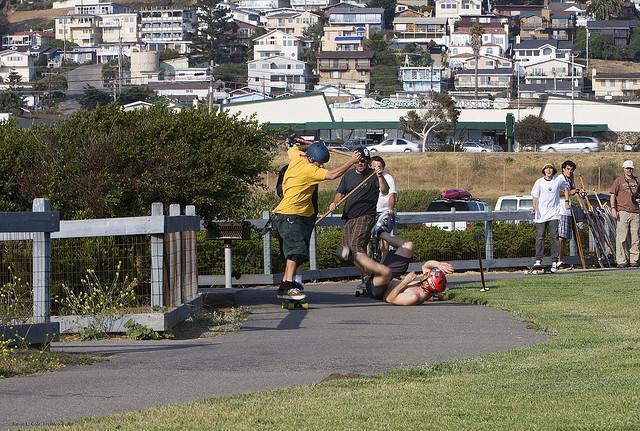How many people are there?
Give a very brief answer. 5. 